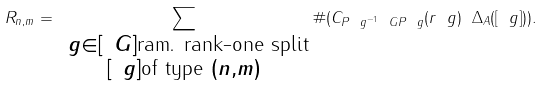<formula> <loc_0><loc_0><loc_500><loc_500>R _ { n , m } = \sum _ { \substack { \ g \in [ \ G ] \text {ram. rank-one split} \\ [ \ g ] \text {of type } ( n , m ) } } \# ( C _ { P _ { \ } g ^ { - 1 } \ G P _ { \ } g } ( r _ { \ } g ) \ \Delta _ { A } ( [ \ g ] ) ) .</formula> 